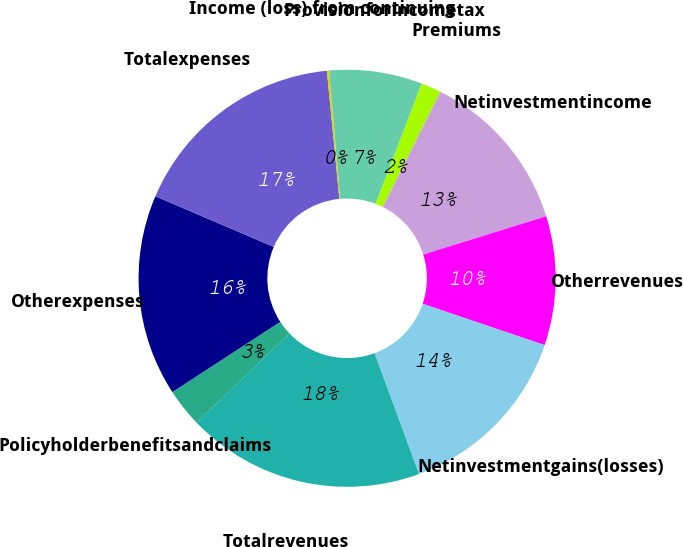Convert chart. <chart><loc_0><loc_0><loc_500><loc_500><pie_chart><fcel>Premiums<fcel>Netinvestmentincome<fcel>Otherrevenues<fcel>Netinvestmentgains(losses)<fcel>Totalrevenues<fcel>Policyholderbenefitsandclaims<fcel>Otherexpenses<fcel>Totalexpenses<fcel>Income (loss) from continuing<fcel>Provisionforincometax<nl><fcel>1.57%<fcel>12.81%<fcel>10.0%<fcel>14.21%<fcel>18.43%<fcel>2.98%<fcel>15.62%<fcel>17.02%<fcel>0.17%<fcel>7.19%<nl></chart> 